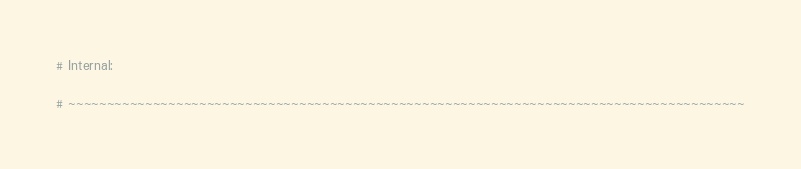Convert code to text. <code><loc_0><loc_0><loc_500><loc_500><_Python_># Internal: 

# ~~~~~~~~~~~~~~~~~~~~~~~~~~~~~~~~~~~~~~~~~~~~~~~~~~~~~~~~~~~~~~~~~~~~~~~~~~~~~~~~~~~~~~~~


</code> 